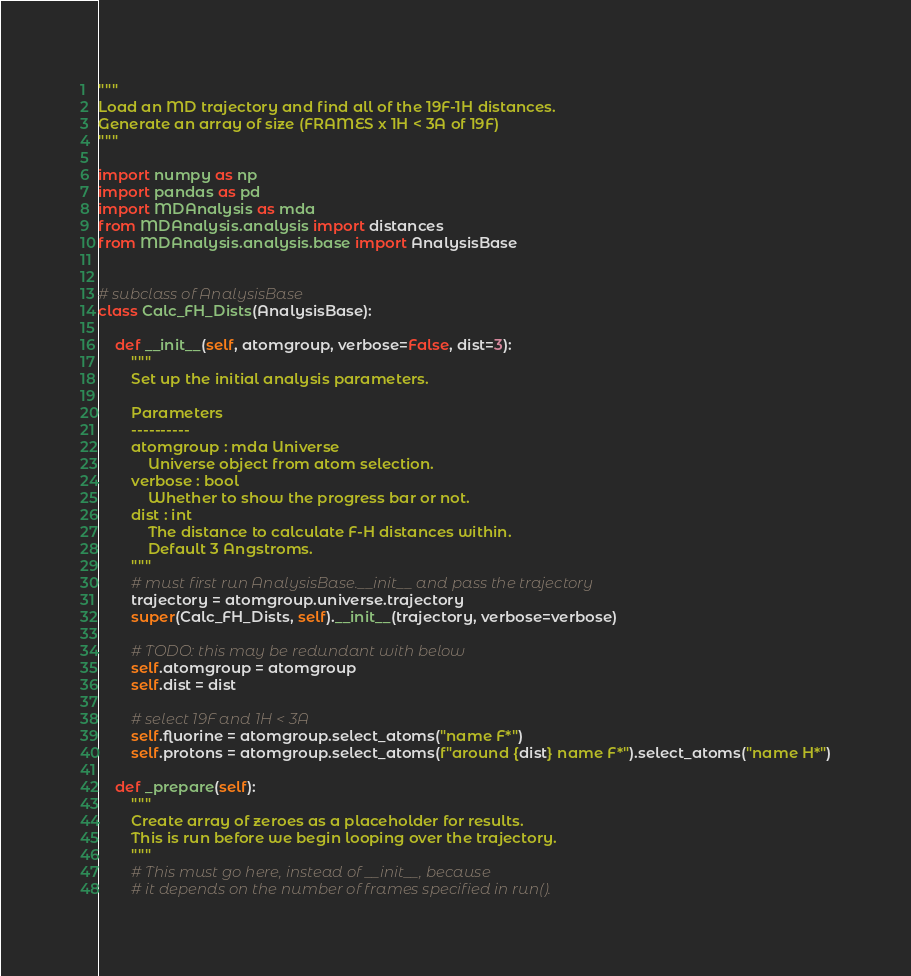Convert code to text. <code><loc_0><loc_0><loc_500><loc_500><_Python_>"""
Load an MD trajectory and find all of the 19F-1H distances.
Generate an array of size (FRAMES x 1H < 3A of 19F) 
"""

import numpy as np
import pandas as pd
import MDAnalysis as mda
from MDAnalysis.analysis import distances
from MDAnalysis.analysis.base import AnalysisBase


# subclass of AnalysisBase
class Calc_FH_Dists(AnalysisBase):

    def __init__(self, atomgroup, verbose=False, dist=3):
        """
        Set up the initial analysis parameters.

        Parameters
        ----------
        atomgroup : mda Universe 
            Universe object from atom selection.
        verbose : bool
            Whether to show the progress bar or not.
        dist : int
            The distance to calculate F-H distances within.
            Default 3 Angstroms.
        """
        # must first run AnalysisBase.__init__ and pass the trajectory
        trajectory = atomgroup.universe.trajectory
        super(Calc_FH_Dists, self).__init__(trajectory, verbose=verbose)

        # TODO: this may be redundant with below
        self.atomgroup = atomgroup
        self.dist = dist

        # select 19F and 1H < 3A
        self.fluorine = atomgroup.select_atoms("name F*")
        self.protons = atomgroup.select_atoms(f"around {dist} name F*").select_atoms("name H*")

    def _prepare(self):
        """
        Create array of zeroes as a placeholder for results.
        This is run before we begin looping over the trajectory.
        """
        # This must go here, instead of __init__, because
        # it depends on the number of frames specified in run().
</code> 